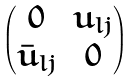Convert formula to latex. <formula><loc_0><loc_0><loc_500><loc_500>\begin{pmatrix} 0 & u _ { l j } \\ \bar { u } _ { l j } & 0 \end{pmatrix}</formula> 